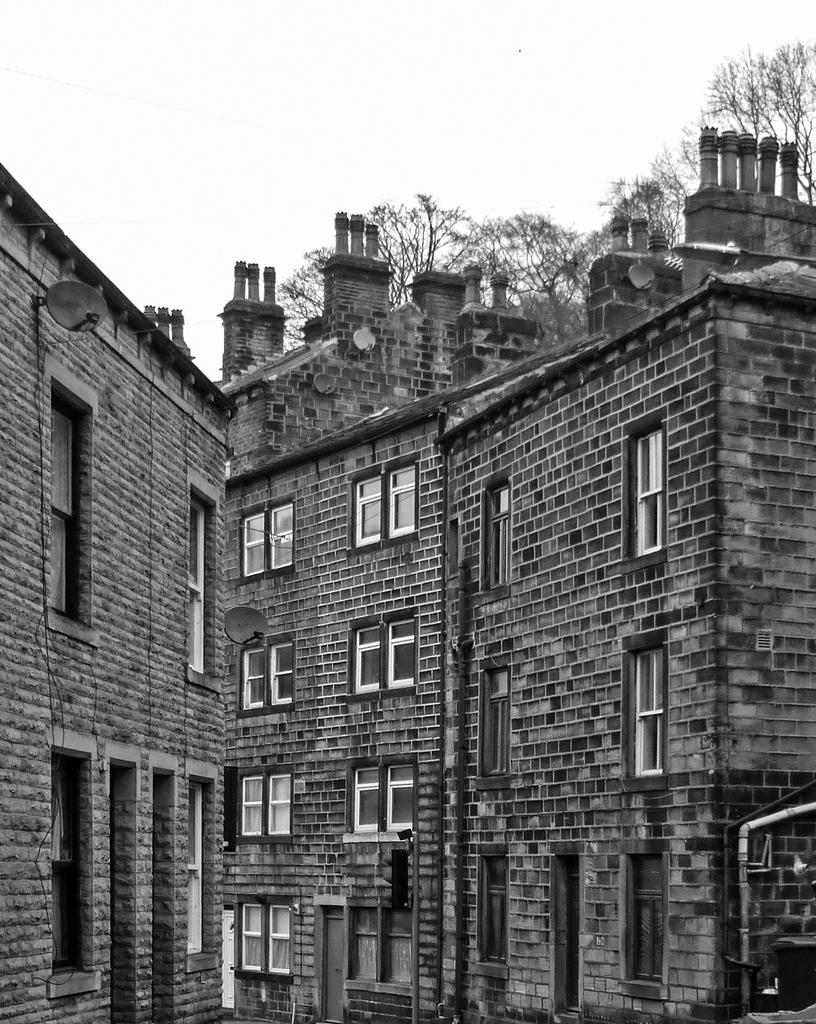What type of structures can be seen in the image? There are buildings in the image. What can be seen in the background of the image? There are trees and the sky visible in the background of the image. What is the color scheme of the image? The image is black and white. What language is spoken by the pest in the image? There is no pest present in the image, so it is not possible to determine what language they might speak. 